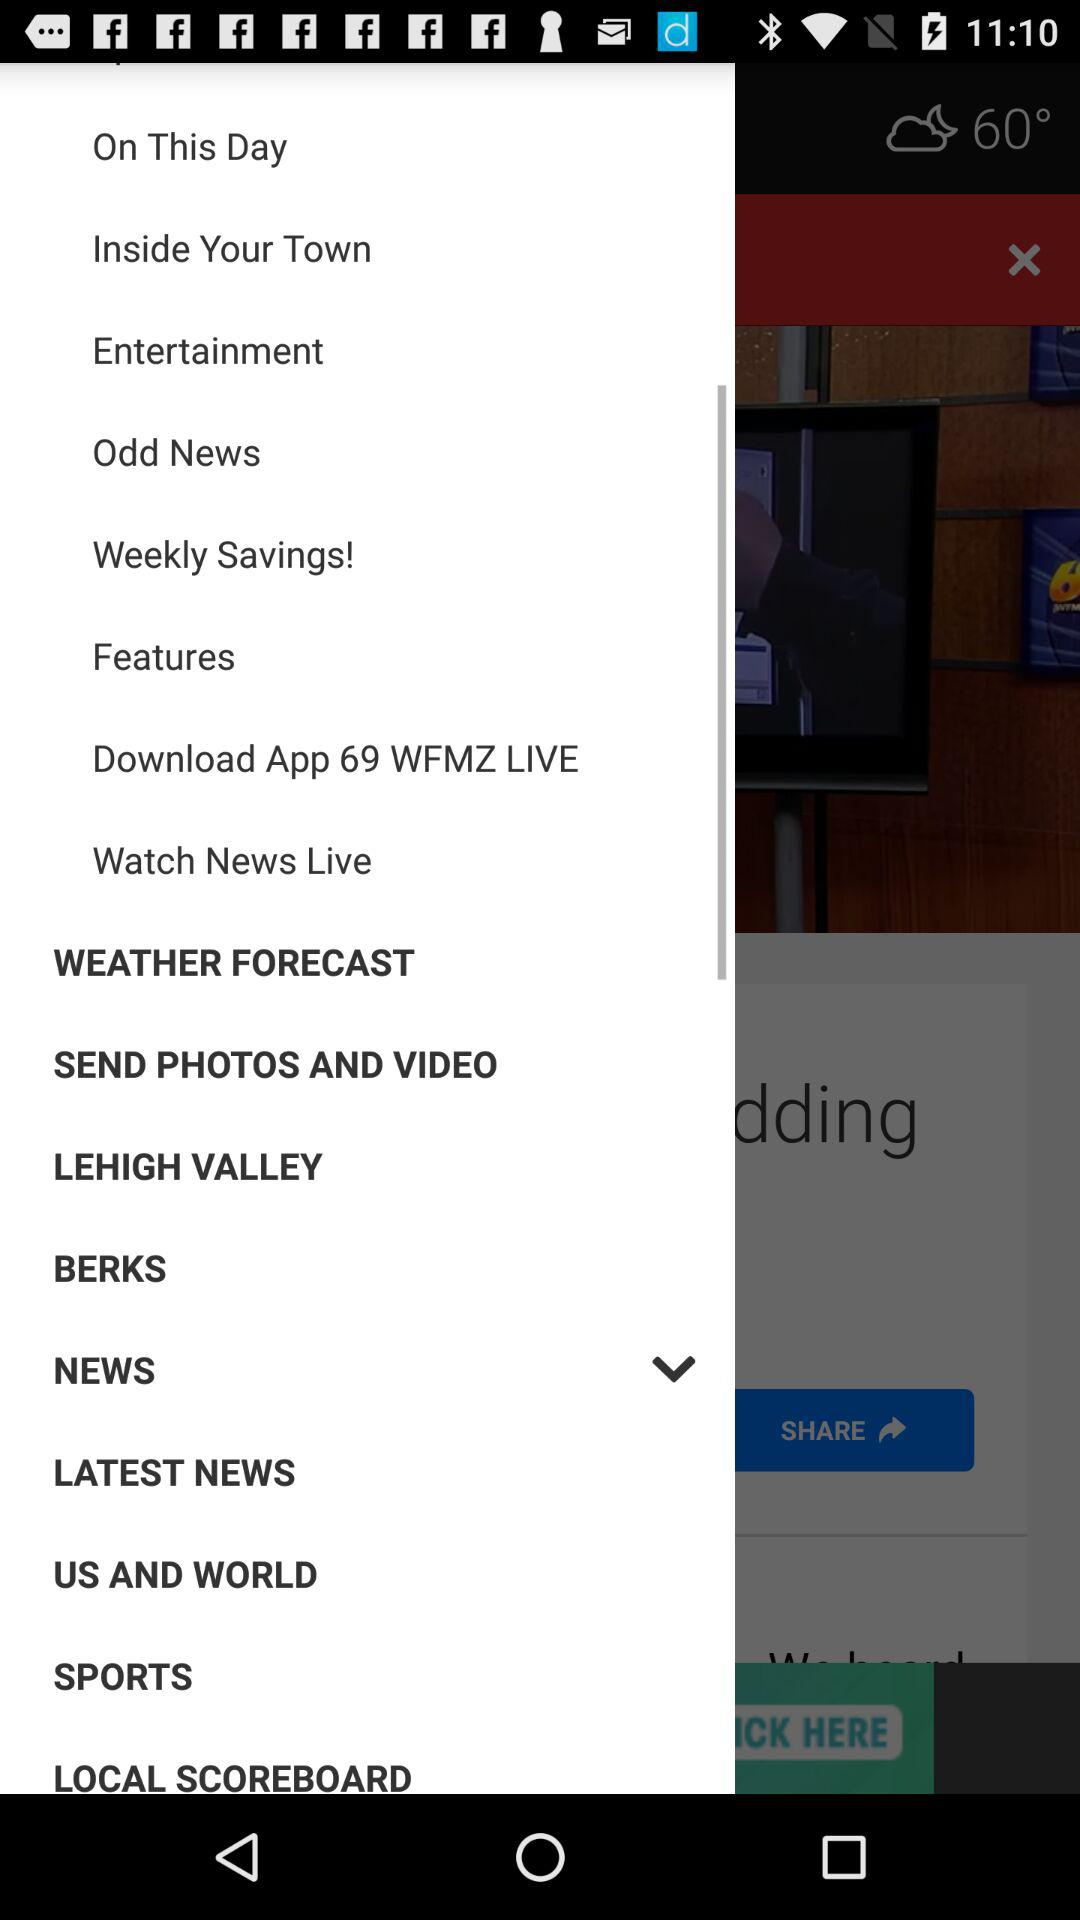What is the given temperature? The given temperature is 60°. 